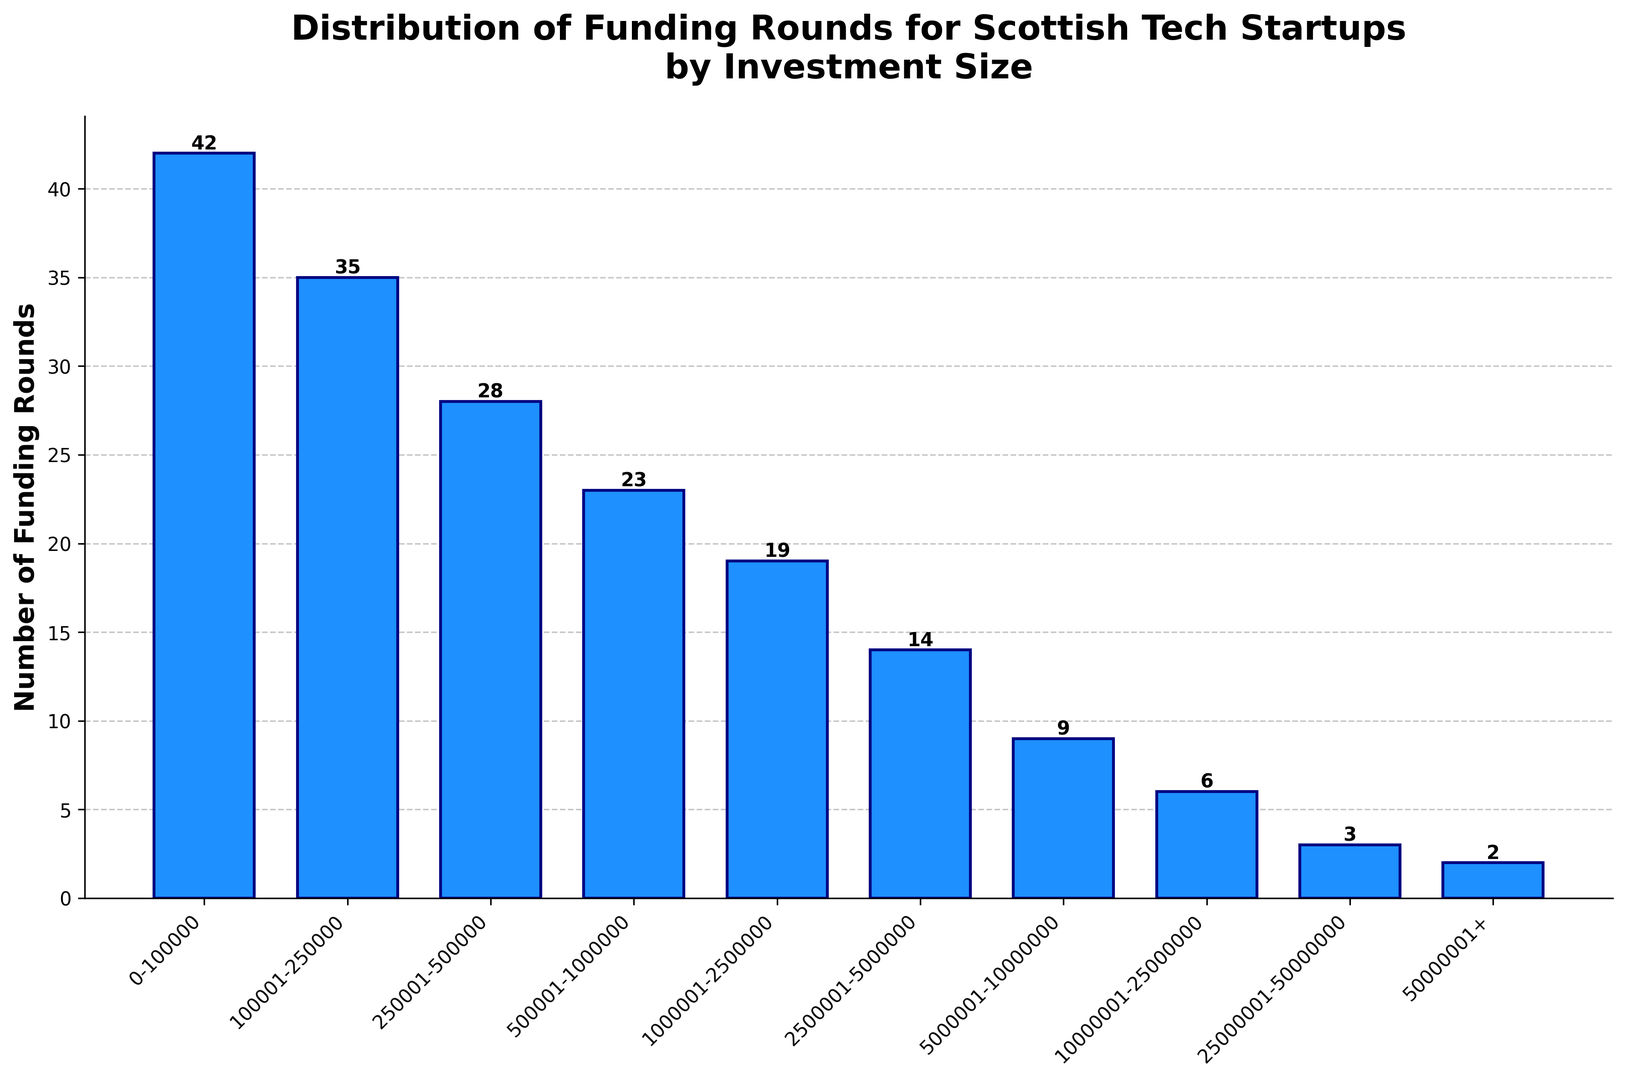What's the most common investment size range for Scottish tech startups based on the number of funding rounds? The highest bar represents the most common investment size range. From the figure, we see that the bar for the "0-100000" category is the tallest with 42 funding rounds.
Answer: 0-100000 Which investment size range has the least number of funding rounds? The shortest bar indicates the least number. From the figure, "50000001+" range has the shortest bar with only 2 funding rounds.
Answer: 50000001+ How many funding rounds are there for investment sizes below £500,001? Sum the number of funding rounds for the ranges: "0-100000", "100001-250000", "250001-500000". That’s 42 + 35 + 28 = 105.
Answer: 105 Which investment size ranges have funding rounds greater than 20 but less than 30? Identify the bars whose height falls within the specified range. The "250001-500000" range has 28 rounds and the "500001-1000000" range has 23 rounds.
Answer: 250001-500000, 500001-1000000 What is the total number of funding rounds for investment sizes of £1,000,001 and above? Sum the funding rounds for the ranges: "1000001-2500000", "2500001-5000000", "5000001-10000000", "10000001-25000000", "25000001-50000000", "50000001+". That’s 19 + 14 + 9 + 6 + 3 + 2 = 53.
Answer: 53 Compare the number of funding rounds between the "0-100000" range and the "500001-1000000" range. Which has more? Compare the heights of these two bars. "0-100000" has 42 rounds, which is greater than the "500001-1000000" with 23 rounds.
Answer: 0-100000 What is the average number of funding rounds per investment range? Add the total number of funding rounds and divide by the number of ranges (10 ranges). Sum: 42+35+28+23+19+14+9+6+3+2 = 181. Average: 181 / 10 = 18.1.
Answer: 18.1 In what investment size range is the funding roughly half of the maximum funding range? The maximum funding range "0-100000" has 42 rounds. Half of that is 21. Check the range close to this value, "500001-1000000" has 23 rounds.
Answer: 500001-1000000 Is the number of funding rounds more variable among lower investment ranges (below £1,000,001) or higher investment ranges (above £1,000,000)? Sum the funding rounds for ranges below £1,000,001 is 42 + 35 + 28 + 23 = 128. Above £1,000,000 is 53 rounds. The variation in lower ranges is higher since it spans from 23 to 42 compared to higher ranges which vary from 2 to 19.
Answer: Lower investment ranges 